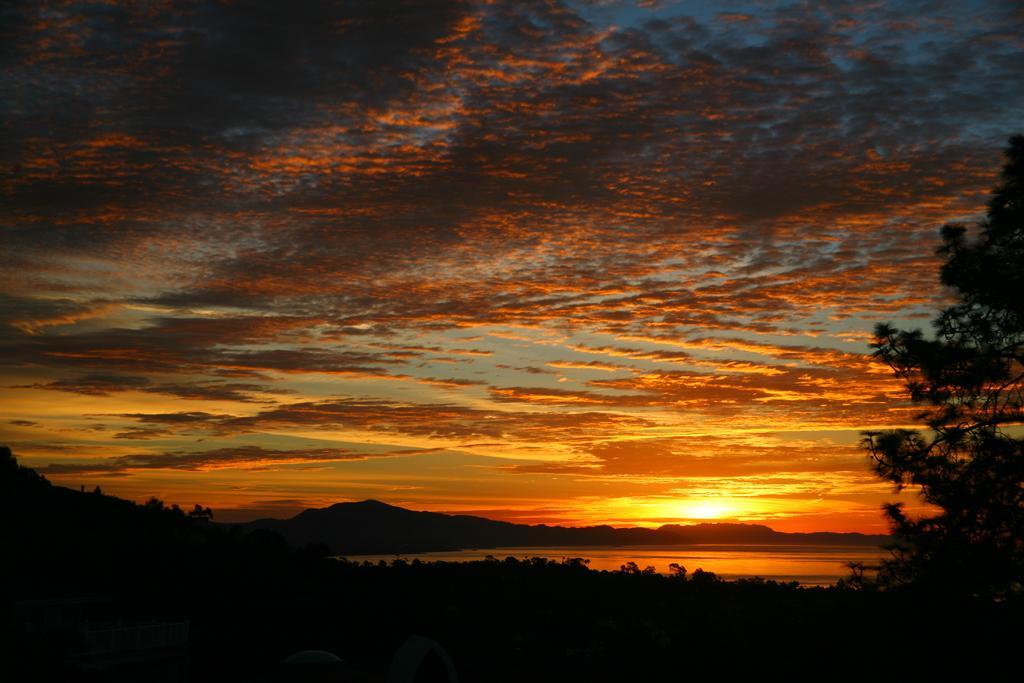Can you describe this image briefly? On the right side, we see the trees. At the bottom, it is black in color. We see some trees at the bottom. There are trees and hills in the background. At the top, we see the sky and the sun. In the middle of the picture, we see the water and this water might be in the pond. 